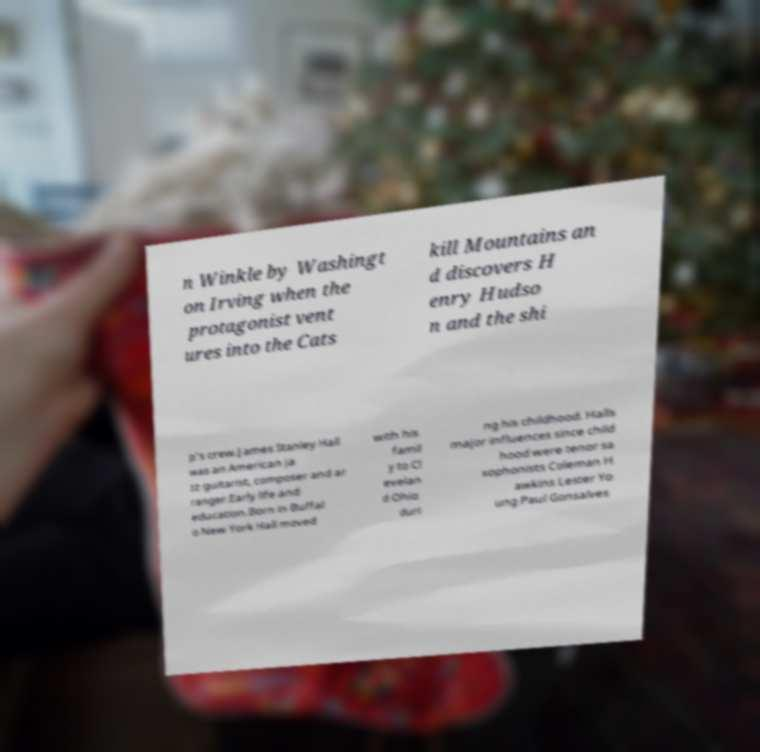Can you accurately transcribe the text from the provided image for me? n Winkle by Washingt on Irving when the protagonist vent ures into the Cats kill Mountains an d discovers H enry Hudso n and the shi p's crew.James Stanley Hall was an American ja zz guitarist, composer and ar ranger.Early life and education.Born in Buffal o New York Hall moved with his famil y to Cl evelan d Ohio duri ng his childhood. Halls major influences since child hood were tenor sa xophonists Coleman H awkins Lester Yo ung Paul Gonsalves 